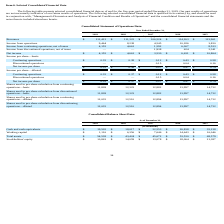From Travelzoo's financial document, What is the value of cash and cash equivalents from 2019 to 2015 respectively? The document contains multiple relevant values: $19,505, $18,017, $22,553, $26,838, $35,128 (in thousands). From the document: "Cash and cash equivalents $ 19,505 $ 18,017 $ 22,553 $ 26,838 $ 35,128 Cash and cash equivalents $ 19,505 $ 18,017 $ 22,553 $ 26,838 $ 35,128 Cash and..." Also, What is the value of working capital from 2019 to 2015 respectively? The document contains multiple relevant values: $1,116, $6,356, $7,646, $14,643, $16,046 (in thousands). From the document: "orking capital $ 1,116 $ 6,356 $ 7,646 $ 14,643 $ 16,046 Working capital $ 1,116 $ 6,356 $ 7,646 $ 14,643 $ 16,046 Working capital $ 1,116 $ 6,356 $ 7..." Also, What should the table show be read in conjunction with? Management's Discussion and Analysis of Financial Condition and Results of Operations” and the consolidated financial statements and the notes thereto included elsewhere herein.. The document states: "rety by, and should be read in conjunction with, “Management's Discussion and Analysis of Financial Condition and Results of Operations” and the conso..." Also, can you calculate: What is the average value of working capital from 2015 to 2019? To answer this question, I need to perform calculations using the financial data. The calculation is: (1,116+ 6,356+ 7,646+ 14,643+16,046)/5, which equals 9161.4 (in thousands). This is based on the information: "Working capital $ 1,116 $ 6,356 $ 7,646 $ 14,643 $ 16,046 Working capital $ 1,116 $ 6,356 $ 7,646 $ 14,643 $ 16,046 Working capital $ 1,116 $ 6,356 $ 7,646 $ 14,643 $ 16,046 orking capital $ 1,116 $ 6..." The key data points involved are: 1,116, 14,643, 16,046. Also, can you calculate: What is the change in the value of total assets between 2019 and 2018? Based on the calculation: 54,538-43,424, the result is 11114 (in thousands). This is based on the information: "Total assets $ 54,538 $ 43,424 $ 45,672 $ 53,530 $ 68,579 Total assets $ 54,538 $ 43,424 $ 45,672 $ 53,530 $ 68,579..." The key data points involved are: 43,424, 54,538. Also, can you calculate: What is the percentage change for cash and cash equivalents between 2018 and 2019? To answer this question, I need to perform calculations using the financial data. The calculation is: (19,505-18,017)/18,017, which equals 8.26 (percentage). This is based on the information: "Cash and cash equivalents $ 19,505 $ 18,017 $ 22,553 $ 26,838 $ 35,128 Cash and cash equivalents $ 19,505 $ 18,017 $ 22,553 $ 26,838 $ 35,128..." The key data points involved are: 18,017, 19,505. 